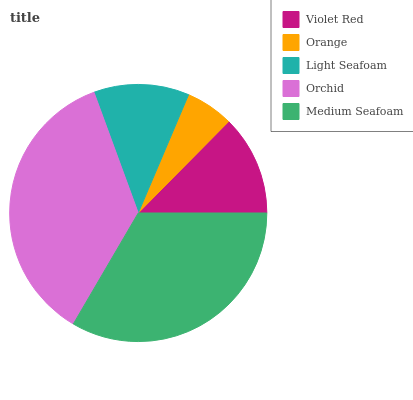Is Orange the minimum?
Answer yes or no. Yes. Is Orchid the maximum?
Answer yes or no. Yes. Is Light Seafoam the minimum?
Answer yes or no. No. Is Light Seafoam the maximum?
Answer yes or no. No. Is Light Seafoam greater than Orange?
Answer yes or no. Yes. Is Orange less than Light Seafoam?
Answer yes or no. Yes. Is Orange greater than Light Seafoam?
Answer yes or no. No. Is Light Seafoam less than Orange?
Answer yes or no. No. Is Violet Red the high median?
Answer yes or no. Yes. Is Violet Red the low median?
Answer yes or no. Yes. Is Orchid the high median?
Answer yes or no. No. Is Orchid the low median?
Answer yes or no. No. 